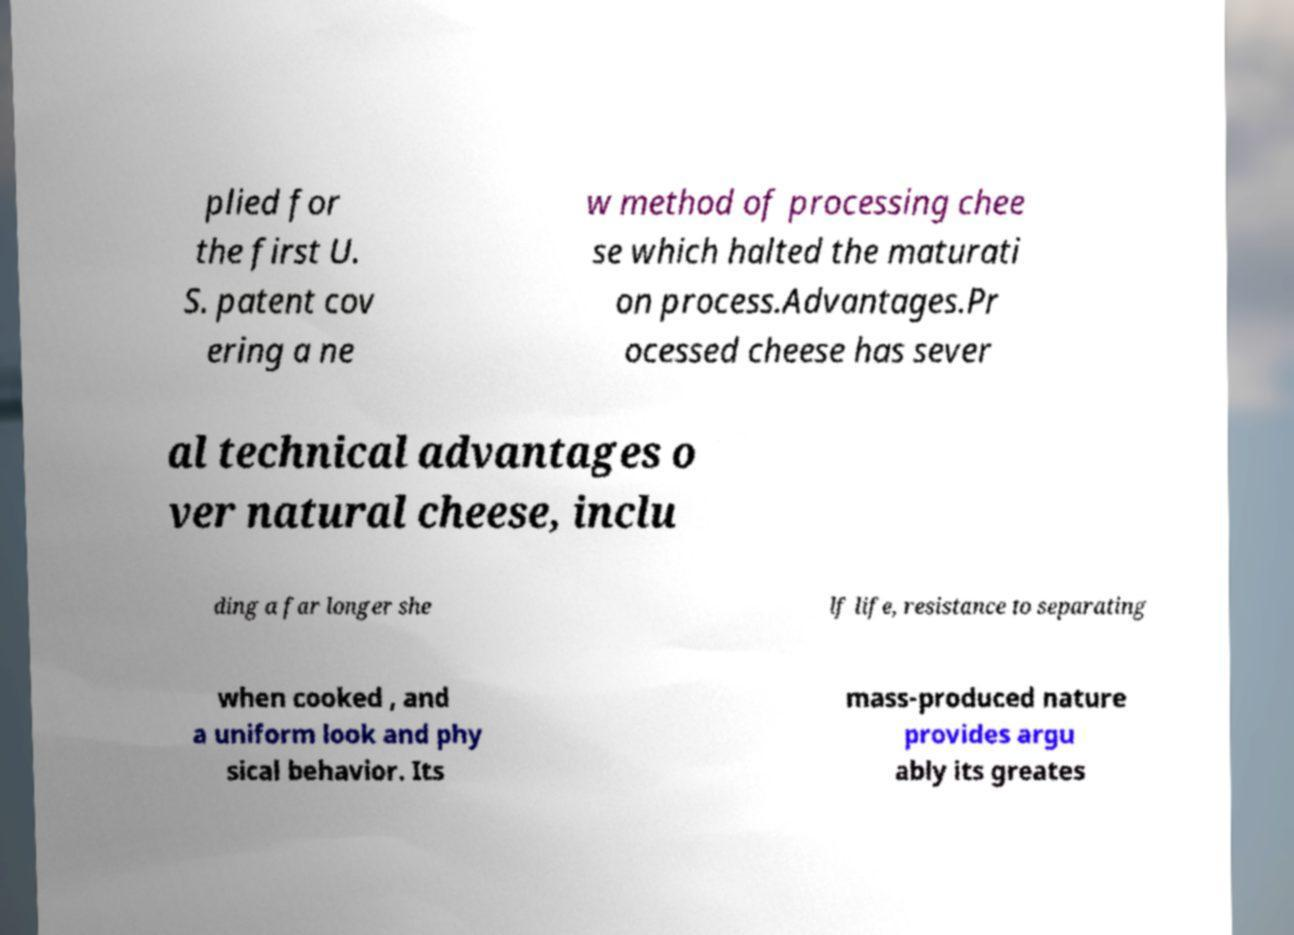There's text embedded in this image that I need extracted. Can you transcribe it verbatim? plied for the first U. S. patent cov ering a ne w method of processing chee se which halted the maturati on process.Advantages.Pr ocessed cheese has sever al technical advantages o ver natural cheese, inclu ding a far longer she lf life, resistance to separating when cooked , and a uniform look and phy sical behavior. Its mass-produced nature provides argu ably its greates 